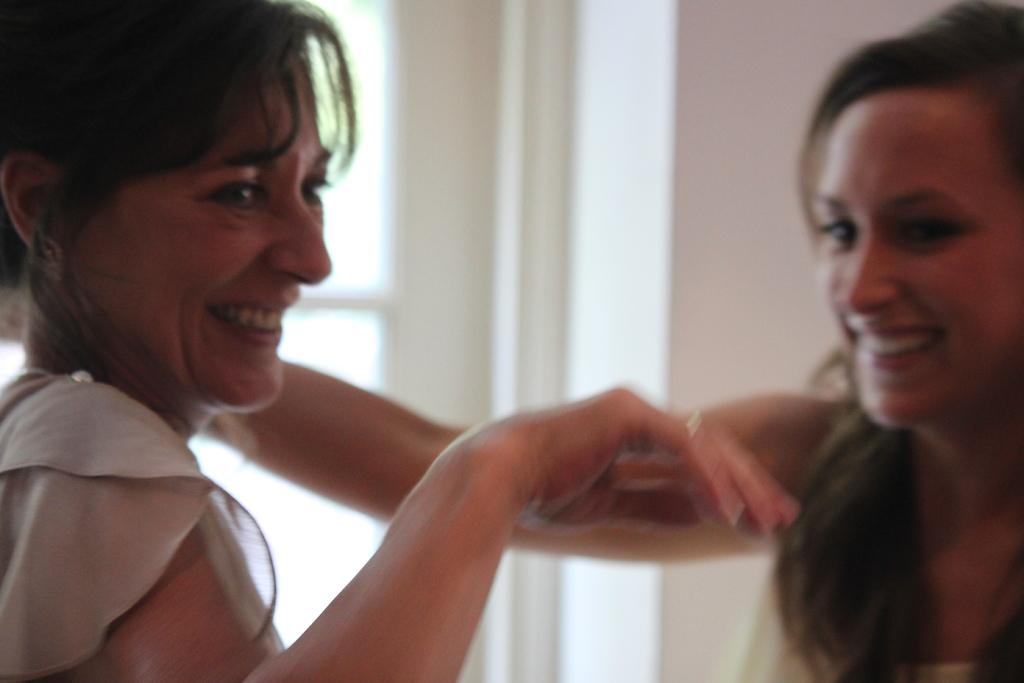How many people are in the image? There are two women in the image. What is the facial expression of the women in the image? The women are smiling. What can be seen in the background of the image? There is a wall in the background of the image. What type of fowl can be seen perched on the wall in the image? There is no fowl present in the image; it only features two women and a wall in the background. 